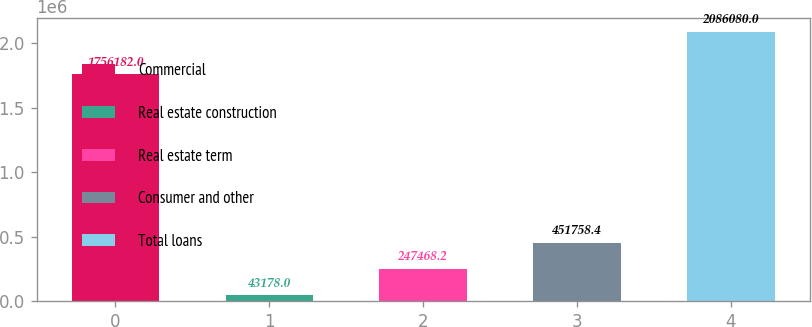Convert chart to OTSL. <chart><loc_0><loc_0><loc_500><loc_500><bar_chart><fcel>Commercial<fcel>Real estate construction<fcel>Real estate term<fcel>Consumer and other<fcel>Total loans<nl><fcel>1.75618e+06<fcel>43178<fcel>247468<fcel>451758<fcel>2.08608e+06<nl></chart> 